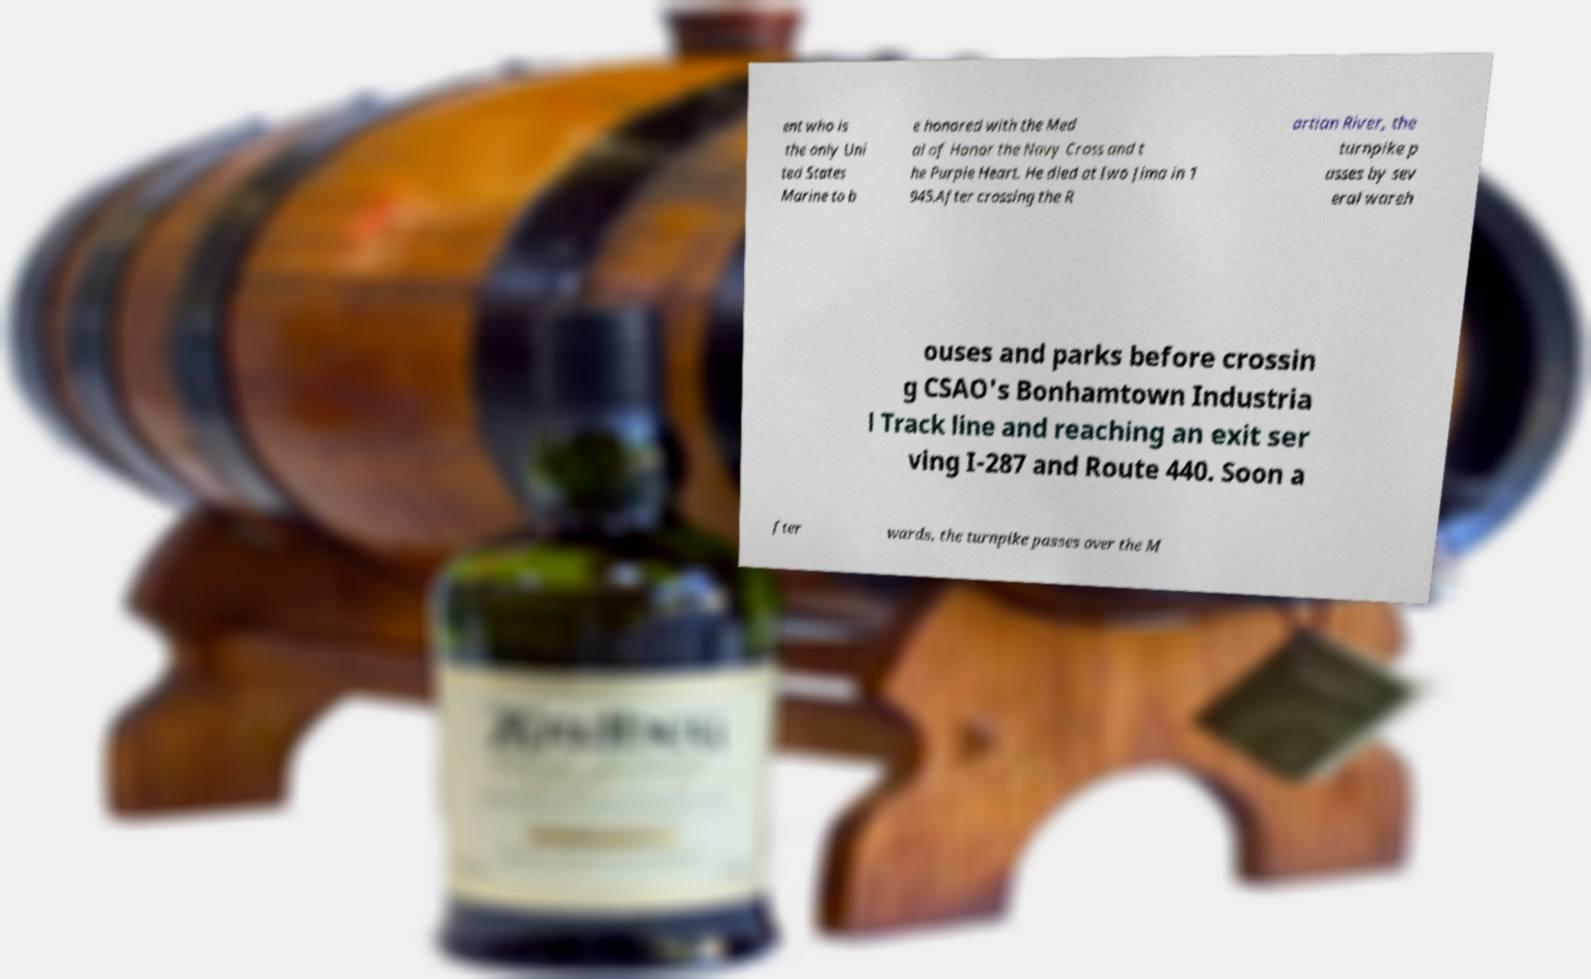Can you accurately transcribe the text from the provided image for me? ent who is the only Uni ted States Marine to b e honored with the Med al of Honor the Navy Cross and t he Purple Heart. He died at Iwo Jima in 1 945.After crossing the R artian River, the turnpike p asses by sev eral wareh ouses and parks before crossin g CSAO's Bonhamtown Industria l Track line and reaching an exit ser ving I-287 and Route 440. Soon a fter wards, the turnpike passes over the M 